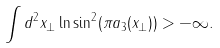Convert formula to latex. <formula><loc_0><loc_0><loc_500><loc_500>\int d ^ { 2 } x _ { \perp } \ln \sin ^ { 2 } ( \pi a _ { 3 } ( x _ { \perp } ) ) > - \infty .</formula> 